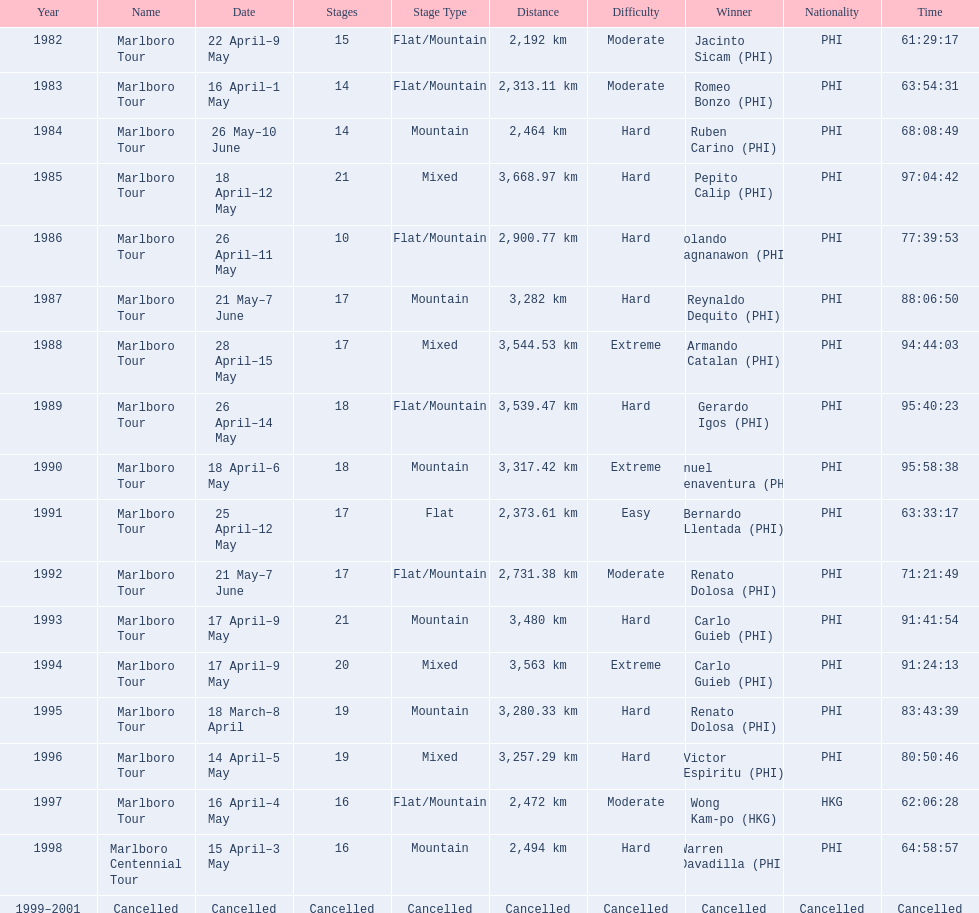What were the tour names during le tour de filipinas? Marlboro Tour, Marlboro Tour, Marlboro Tour, Marlboro Tour, Marlboro Tour, Marlboro Tour, Marlboro Tour, Marlboro Tour, Marlboro Tour, Marlboro Tour, Marlboro Tour, Marlboro Tour, Marlboro Tour, Marlboro Tour, Marlboro Tour, Marlboro Tour, Marlboro Centennial Tour, Cancelled. What were the recorded distances for each marlboro tour? 2,192 km, 2,313.11 km, 2,464 km, 3,668.97 km, 2,900.77 km, 3,282 km, 3,544.53 km, 3,539.47 km, 3,317.42 km, 2,373.61 km, 2,731.38 km, 3,480 km, 3,563 km, 3,280.33 km, 3,257.29 km, 2,472 km. And of those distances, which was the longest? 3,668.97 km. 